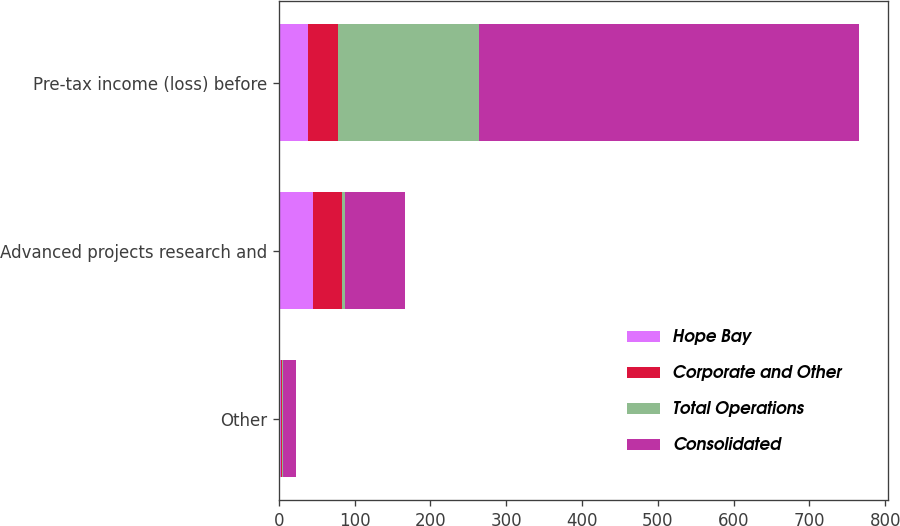<chart> <loc_0><loc_0><loc_500><loc_500><stacked_bar_chart><ecel><fcel>Other<fcel>Advanced projects research and<fcel>Pre-tax income (loss) before<nl><fcel>Hope Bay<fcel>3<fcel>45<fcel>39<nl><fcel>Corporate and Other<fcel>1<fcel>39<fcel>39<nl><fcel>Total Operations<fcel>1<fcel>3<fcel>186<nl><fcel>Consolidated<fcel>18<fcel>79<fcel>501<nl></chart> 